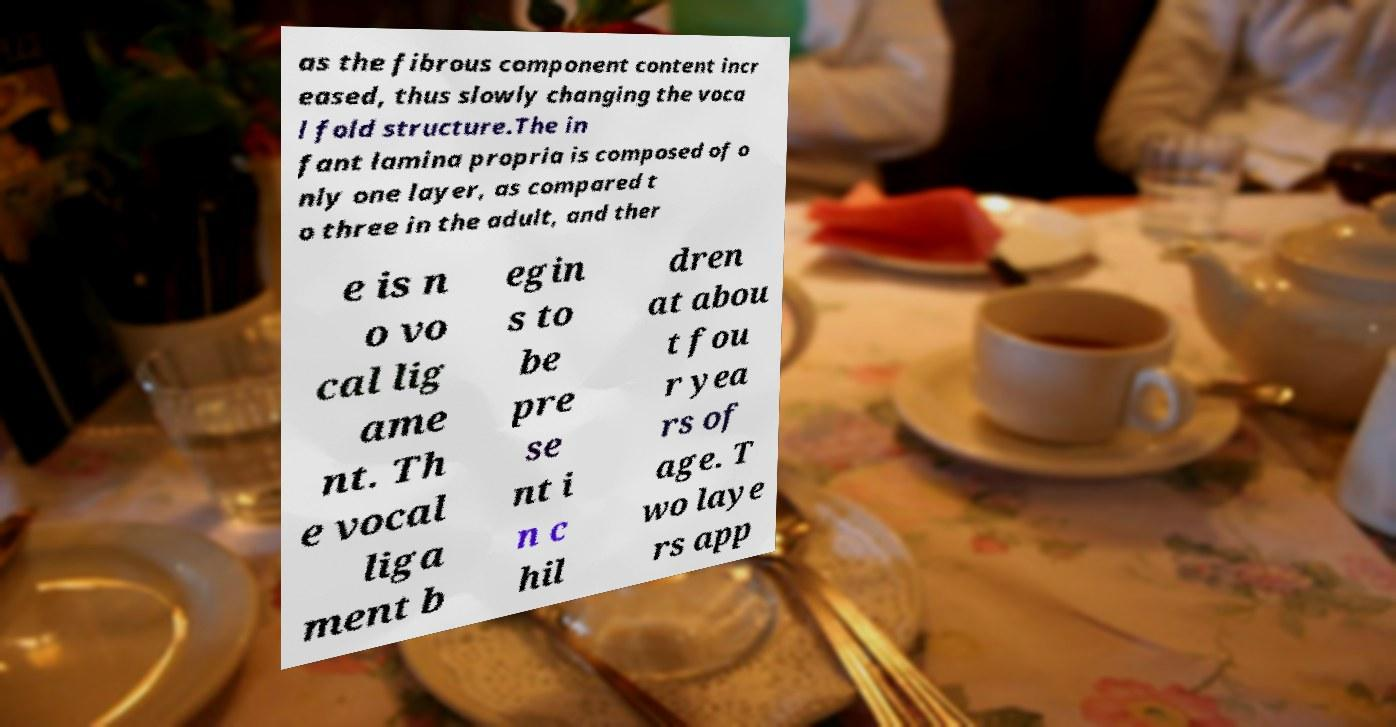There's text embedded in this image that I need extracted. Can you transcribe it verbatim? as the fibrous component content incr eased, thus slowly changing the voca l fold structure.The in fant lamina propria is composed of o nly one layer, as compared t o three in the adult, and ther e is n o vo cal lig ame nt. Th e vocal liga ment b egin s to be pre se nt i n c hil dren at abou t fou r yea rs of age. T wo laye rs app 